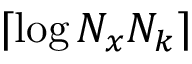Convert formula to latex. <formula><loc_0><loc_0><loc_500><loc_500>\lceil \log N _ { x } N _ { k } \rceil</formula> 